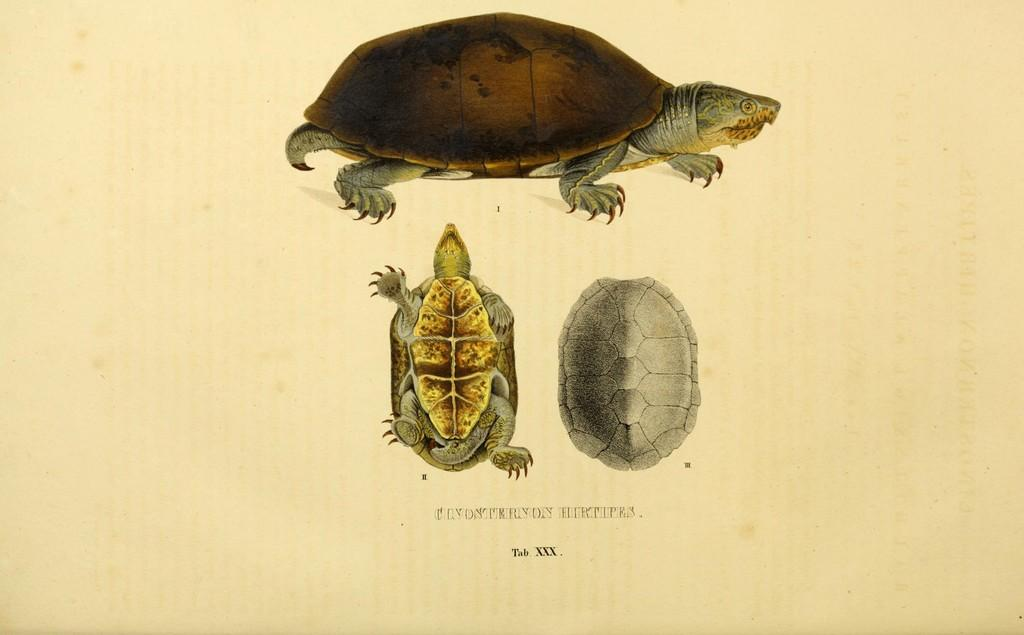What can be found in the image that contains written information? There is text in the image. What type of animals are depicted in the image? There are reptile images in the image. How many beads are present in the image? There is no mention of beads in the image, so it is impossible to determine their presence or quantity. 